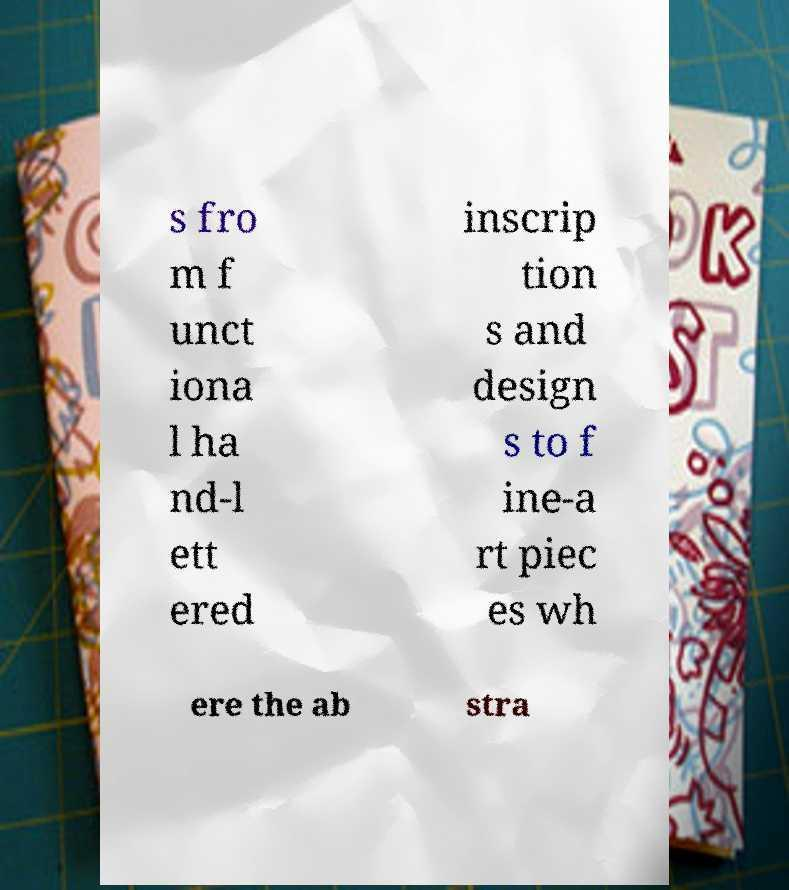What messages or text are displayed in this image? I need them in a readable, typed format. s fro m f unct iona l ha nd-l ett ered inscrip tion s and design s to f ine-a rt piec es wh ere the ab stra 